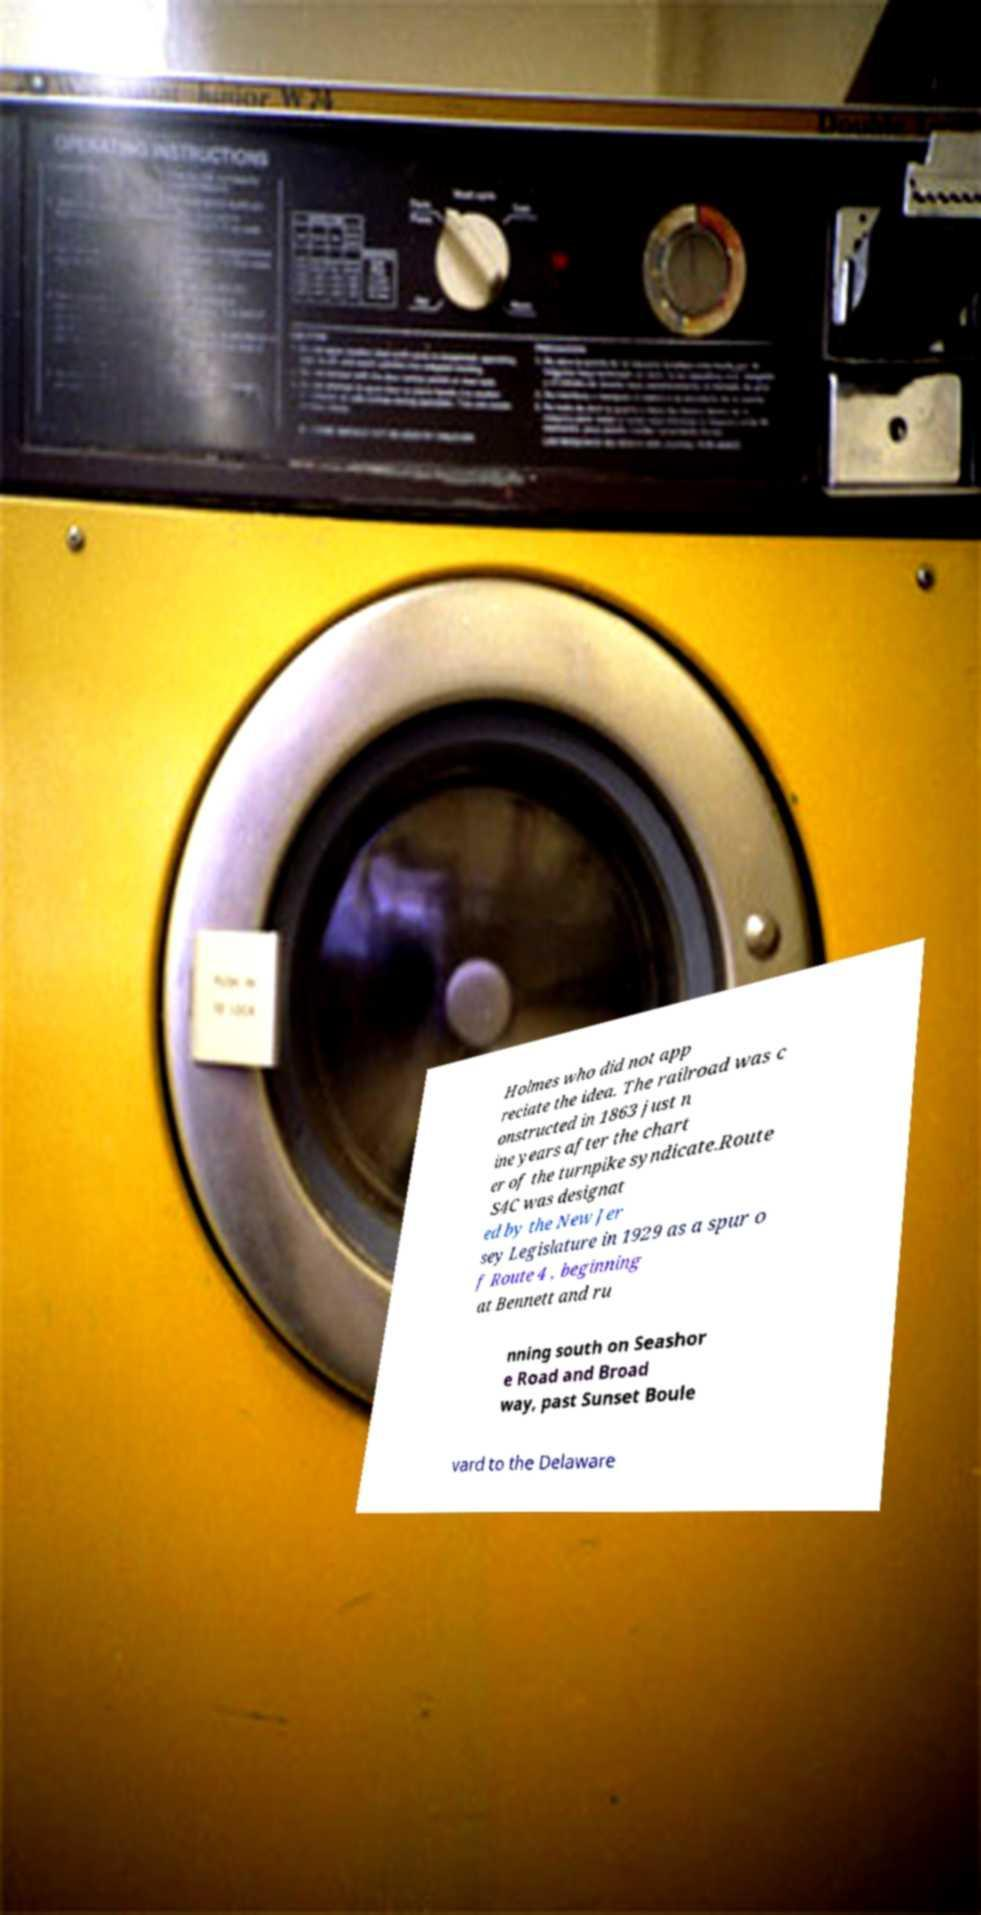For documentation purposes, I need the text within this image transcribed. Could you provide that? Holmes who did not app reciate the idea. The railroad was c onstructed in 1863 just n ine years after the chart er of the turnpike syndicate.Route S4C was designat ed by the New Jer sey Legislature in 1929 as a spur o f Route 4 , beginning at Bennett and ru nning south on Seashor e Road and Broad way, past Sunset Boule vard to the Delaware 